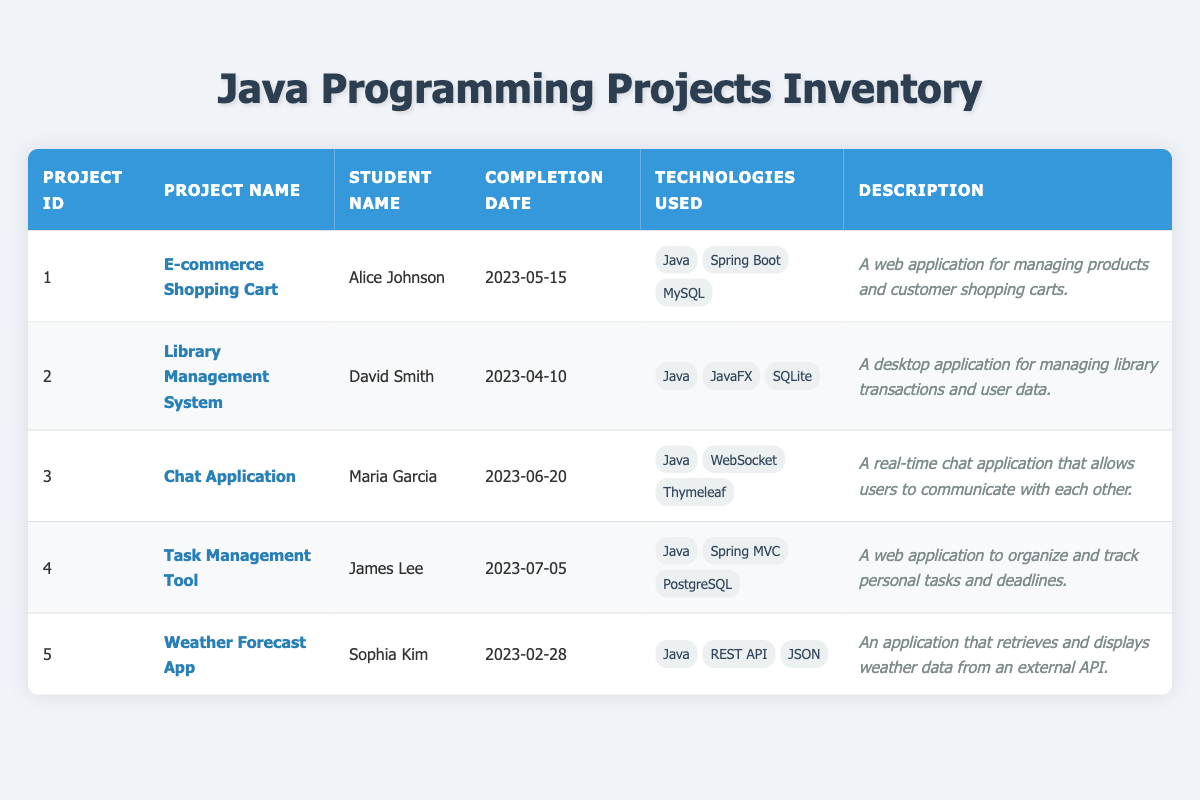What is the project name completed by Alice Johnson? Alice Johnson completed the "E-commerce Shopping Cart" project, which can be found in the table under her name in the Student Name column.
Answer: E-commerce Shopping Cart Which technologies are used in the Chat Application? The technologies used in the Chat Application are listed in the Technologies Used column next to the respective project, which include Java, WebSocket, and Thymeleaf.
Answer: Java, WebSocket, Thymeleaf Was there a project completed on or after July 1, 2023? To check for a project completed on or after July 1, 2023, we look at the Completion Date column. The Task Management Tool (completed on July 5, 2023) qualifies, making the answer yes.
Answer: Yes Who completed the Library Management System project? The student who completed the Library Management System is listed in the Student Name column next to the corresponding project id of 2. The entry shows that David Smith is the person who completed it.
Answer: David Smith How many projects utilized Spring Boot? To find the number of projects that utilized Spring Boot, we can review the Technologies Used column for any mentions of Spring Boot. Two projects (E-commerce Shopping Cart and Task Management Tool) used this technology, so the total is 2.
Answer: 2 Is the Weather Forecast App a web application? The description column for the Weather Forecast App states that it retrieves weather data from an external API, but does not explicitly mention it being a web application as its main architecture is not listed. Thus, it is a no.
Answer: No Which project was completed the earliest? To find the earliest completed project, we need to check the Completion Date column and identify the earliest date. The Weather Forecast App has the date of February 28, 2023, which is earlier than all others listed.
Answer: Weather Forecast App Which is the latest completed project, and who completed it? The latest completed project is found by checking the Completion Date column for the most recent date. The Task Management Tool, completed on July 5, 2023, was completed by James Lee.
Answer: Task Management Tool, James Lee What percentage of the projects used a REST API? There are 5 projects total, and only 1 project (the Weather Forecast App) used a REST API. The percentage is calculated as (1/5) * 100 = 20%.
Answer: 20% 